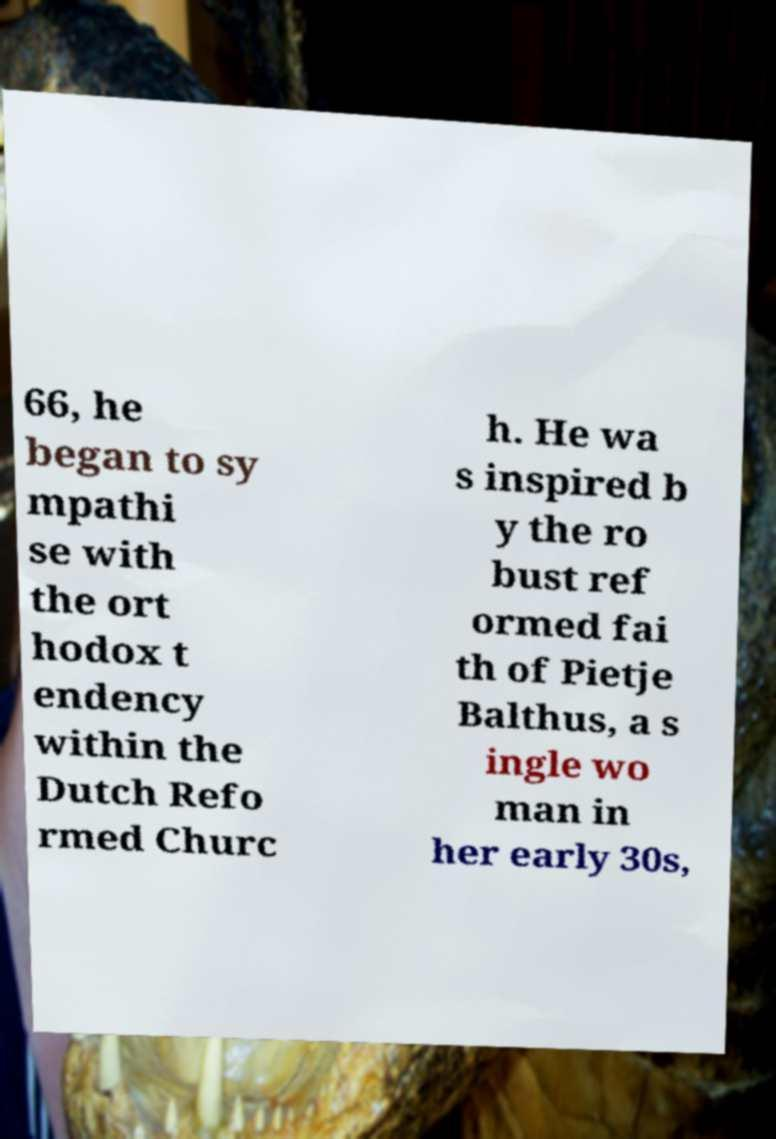Please identify and transcribe the text found in this image. 66, he began to sy mpathi se with the ort hodox t endency within the Dutch Refo rmed Churc h. He wa s inspired b y the ro bust ref ormed fai th of Pietje Balthus, a s ingle wo man in her early 30s, 